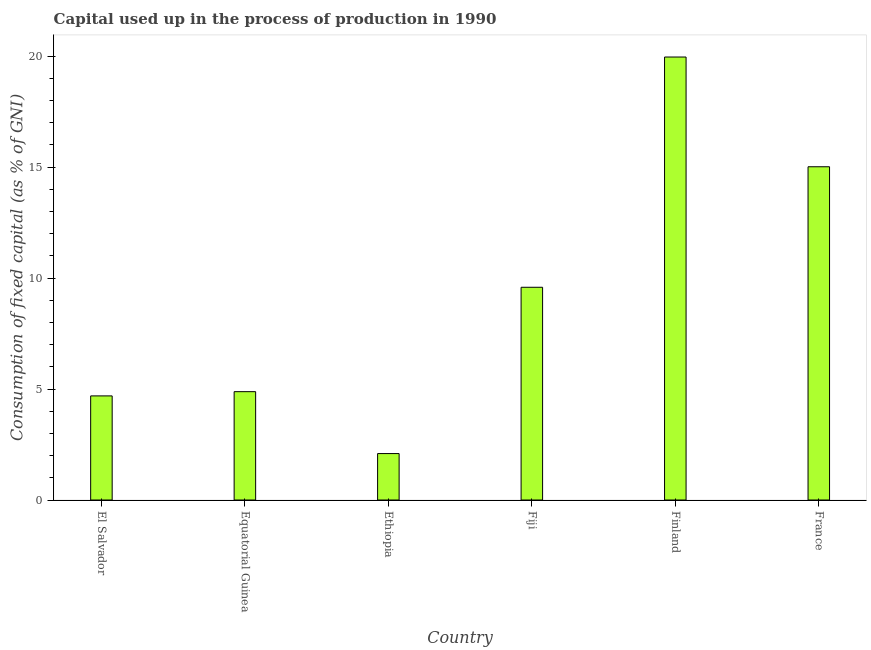Does the graph contain any zero values?
Your answer should be very brief. No. Does the graph contain grids?
Provide a succinct answer. No. What is the title of the graph?
Offer a very short reply. Capital used up in the process of production in 1990. What is the label or title of the Y-axis?
Offer a terse response. Consumption of fixed capital (as % of GNI). What is the consumption of fixed capital in France?
Provide a short and direct response. 15.01. Across all countries, what is the maximum consumption of fixed capital?
Keep it short and to the point. 19.96. Across all countries, what is the minimum consumption of fixed capital?
Your answer should be very brief. 2.09. In which country was the consumption of fixed capital maximum?
Provide a succinct answer. Finland. In which country was the consumption of fixed capital minimum?
Your answer should be very brief. Ethiopia. What is the sum of the consumption of fixed capital?
Keep it short and to the point. 56.22. What is the difference between the consumption of fixed capital in Fiji and France?
Provide a short and direct response. -5.43. What is the average consumption of fixed capital per country?
Offer a very short reply. 9.37. What is the median consumption of fixed capital?
Keep it short and to the point. 7.23. In how many countries, is the consumption of fixed capital greater than 16 %?
Offer a very short reply. 1. What is the ratio of the consumption of fixed capital in Equatorial Guinea to that in France?
Make the answer very short. 0.33. Is the consumption of fixed capital in Equatorial Guinea less than that in Ethiopia?
Your answer should be compact. No. Is the difference between the consumption of fixed capital in Ethiopia and Finland greater than the difference between any two countries?
Offer a very short reply. Yes. What is the difference between the highest and the second highest consumption of fixed capital?
Offer a very short reply. 4.94. Is the sum of the consumption of fixed capital in Fiji and Finland greater than the maximum consumption of fixed capital across all countries?
Offer a terse response. Yes. What is the difference between the highest and the lowest consumption of fixed capital?
Provide a short and direct response. 17.86. Are all the bars in the graph horizontal?
Provide a short and direct response. No. How many countries are there in the graph?
Make the answer very short. 6. What is the difference between two consecutive major ticks on the Y-axis?
Ensure brevity in your answer.  5. Are the values on the major ticks of Y-axis written in scientific E-notation?
Keep it short and to the point. No. What is the Consumption of fixed capital (as % of GNI) of El Salvador?
Your answer should be compact. 4.69. What is the Consumption of fixed capital (as % of GNI) in Equatorial Guinea?
Keep it short and to the point. 4.88. What is the Consumption of fixed capital (as % of GNI) in Ethiopia?
Your answer should be compact. 2.09. What is the Consumption of fixed capital (as % of GNI) in Fiji?
Give a very brief answer. 9.58. What is the Consumption of fixed capital (as % of GNI) in Finland?
Your answer should be compact. 19.96. What is the Consumption of fixed capital (as % of GNI) of France?
Your answer should be very brief. 15.01. What is the difference between the Consumption of fixed capital (as % of GNI) in El Salvador and Equatorial Guinea?
Your response must be concise. -0.19. What is the difference between the Consumption of fixed capital (as % of GNI) in El Salvador and Ethiopia?
Ensure brevity in your answer.  2.6. What is the difference between the Consumption of fixed capital (as % of GNI) in El Salvador and Fiji?
Offer a very short reply. -4.89. What is the difference between the Consumption of fixed capital (as % of GNI) in El Salvador and Finland?
Make the answer very short. -15.27. What is the difference between the Consumption of fixed capital (as % of GNI) in El Salvador and France?
Offer a very short reply. -10.32. What is the difference between the Consumption of fixed capital (as % of GNI) in Equatorial Guinea and Ethiopia?
Your answer should be compact. 2.79. What is the difference between the Consumption of fixed capital (as % of GNI) in Equatorial Guinea and Fiji?
Your answer should be very brief. -4.7. What is the difference between the Consumption of fixed capital (as % of GNI) in Equatorial Guinea and Finland?
Offer a very short reply. -15.08. What is the difference between the Consumption of fixed capital (as % of GNI) in Equatorial Guinea and France?
Make the answer very short. -10.13. What is the difference between the Consumption of fixed capital (as % of GNI) in Ethiopia and Fiji?
Keep it short and to the point. -7.49. What is the difference between the Consumption of fixed capital (as % of GNI) in Ethiopia and Finland?
Offer a very short reply. -17.86. What is the difference between the Consumption of fixed capital (as % of GNI) in Ethiopia and France?
Offer a terse response. -12.92. What is the difference between the Consumption of fixed capital (as % of GNI) in Fiji and Finland?
Offer a very short reply. -10.37. What is the difference between the Consumption of fixed capital (as % of GNI) in Fiji and France?
Your answer should be compact. -5.43. What is the difference between the Consumption of fixed capital (as % of GNI) in Finland and France?
Your response must be concise. 4.94. What is the ratio of the Consumption of fixed capital (as % of GNI) in El Salvador to that in Ethiopia?
Keep it short and to the point. 2.24. What is the ratio of the Consumption of fixed capital (as % of GNI) in El Salvador to that in Fiji?
Give a very brief answer. 0.49. What is the ratio of the Consumption of fixed capital (as % of GNI) in El Salvador to that in Finland?
Ensure brevity in your answer.  0.23. What is the ratio of the Consumption of fixed capital (as % of GNI) in El Salvador to that in France?
Make the answer very short. 0.31. What is the ratio of the Consumption of fixed capital (as % of GNI) in Equatorial Guinea to that in Ethiopia?
Your response must be concise. 2.33. What is the ratio of the Consumption of fixed capital (as % of GNI) in Equatorial Guinea to that in Fiji?
Your response must be concise. 0.51. What is the ratio of the Consumption of fixed capital (as % of GNI) in Equatorial Guinea to that in Finland?
Your answer should be very brief. 0.24. What is the ratio of the Consumption of fixed capital (as % of GNI) in Equatorial Guinea to that in France?
Offer a very short reply. 0.33. What is the ratio of the Consumption of fixed capital (as % of GNI) in Ethiopia to that in Fiji?
Provide a short and direct response. 0.22. What is the ratio of the Consumption of fixed capital (as % of GNI) in Ethiopia to that in Finland?
Your answer should be very brief. 0.1. What is the ratio of the Consumption of fixed capital (as % of GNI) in Ethiopia to that in France?
Make the answer very short. 0.14. What is the ratio of the Consumption of fixed capital (as % of GNI) in Fiji to that in Finland?
Make the answer very short. 0.48. What is the ratio of the Consumption of fixed capital (as % of GNI) in Fiji to that in France?
Offer a terse response. 0.64. What is the ratio of the Consumption of fixed capital (as % of GNI) in Finland to that in France?
Keep it short and to the point. 1.33. 